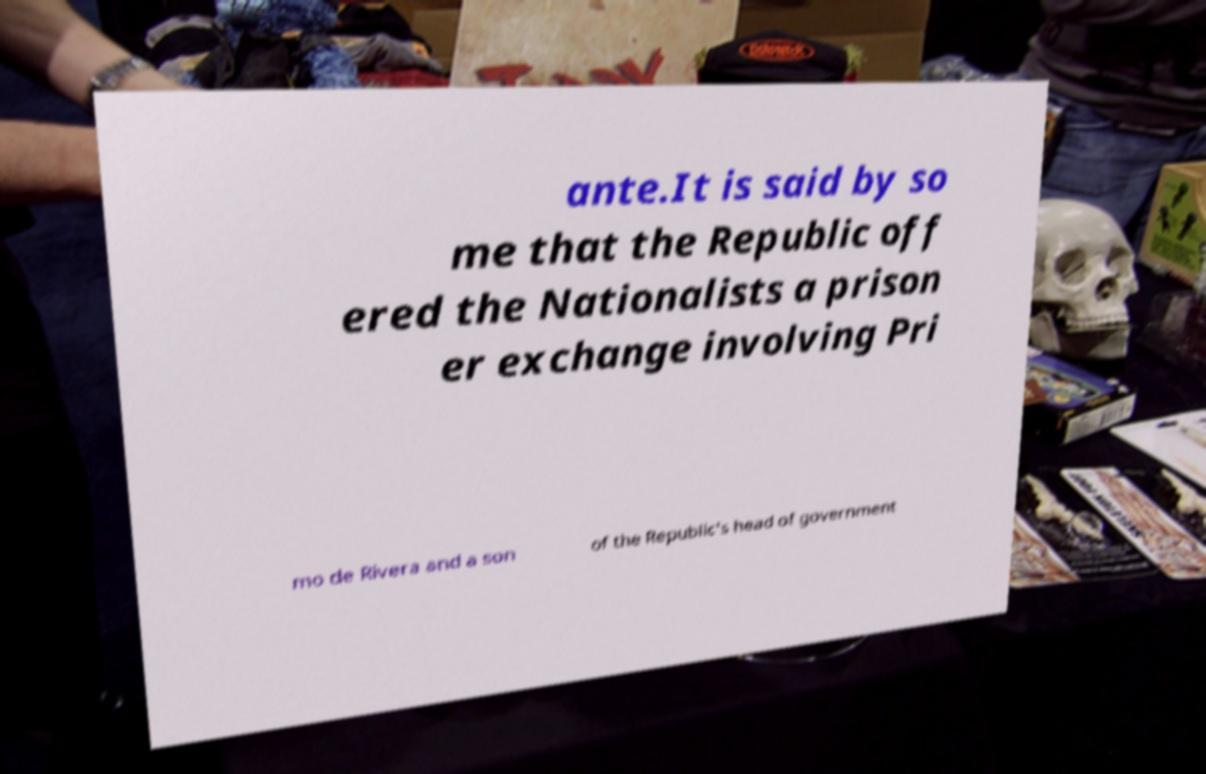Could you extract and type out the text from this image? ante.It is said by so me that the Republic off ered the Nationalists a prison er exchange involving Pri mo de Rivera and a son of the Republic's head of government 